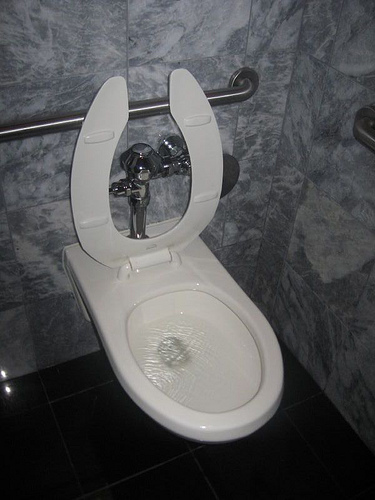<image>Is there water in the seat? I don't know if there is water in the seat. It could be either yes or no. Is there water in the seat? I don't know if there is water in the seat. It can be both yes and no. 